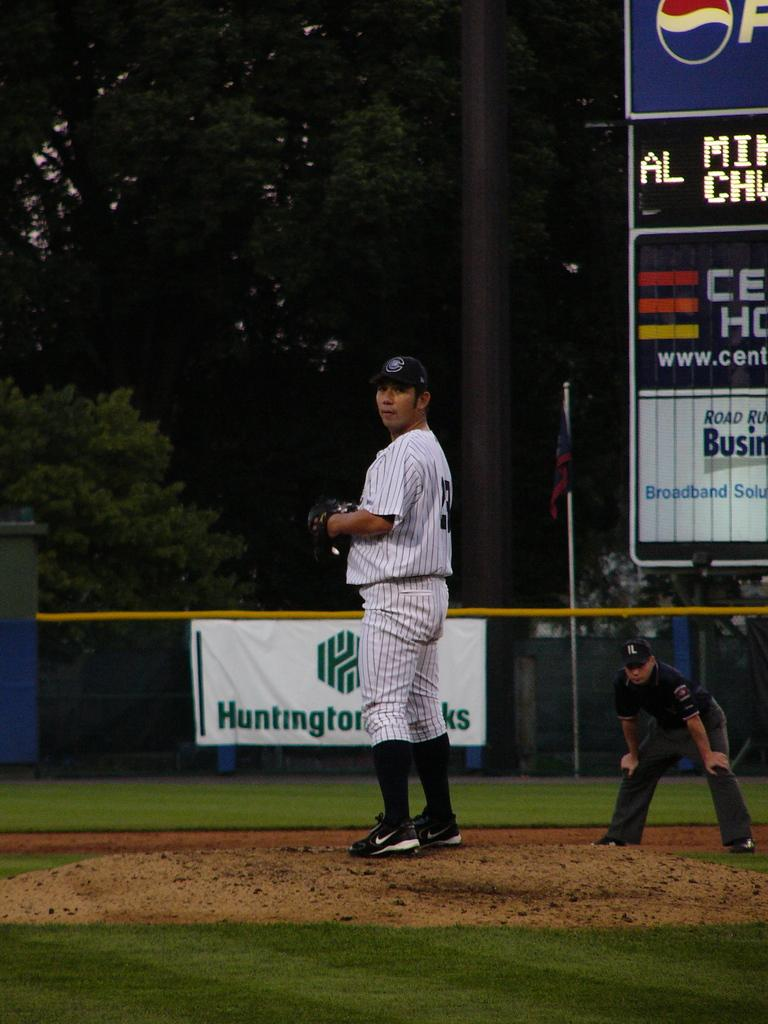Provide a one-sentence caption for the provided image. A sign with the word Huntington on it can be seen behind a baseball player. 